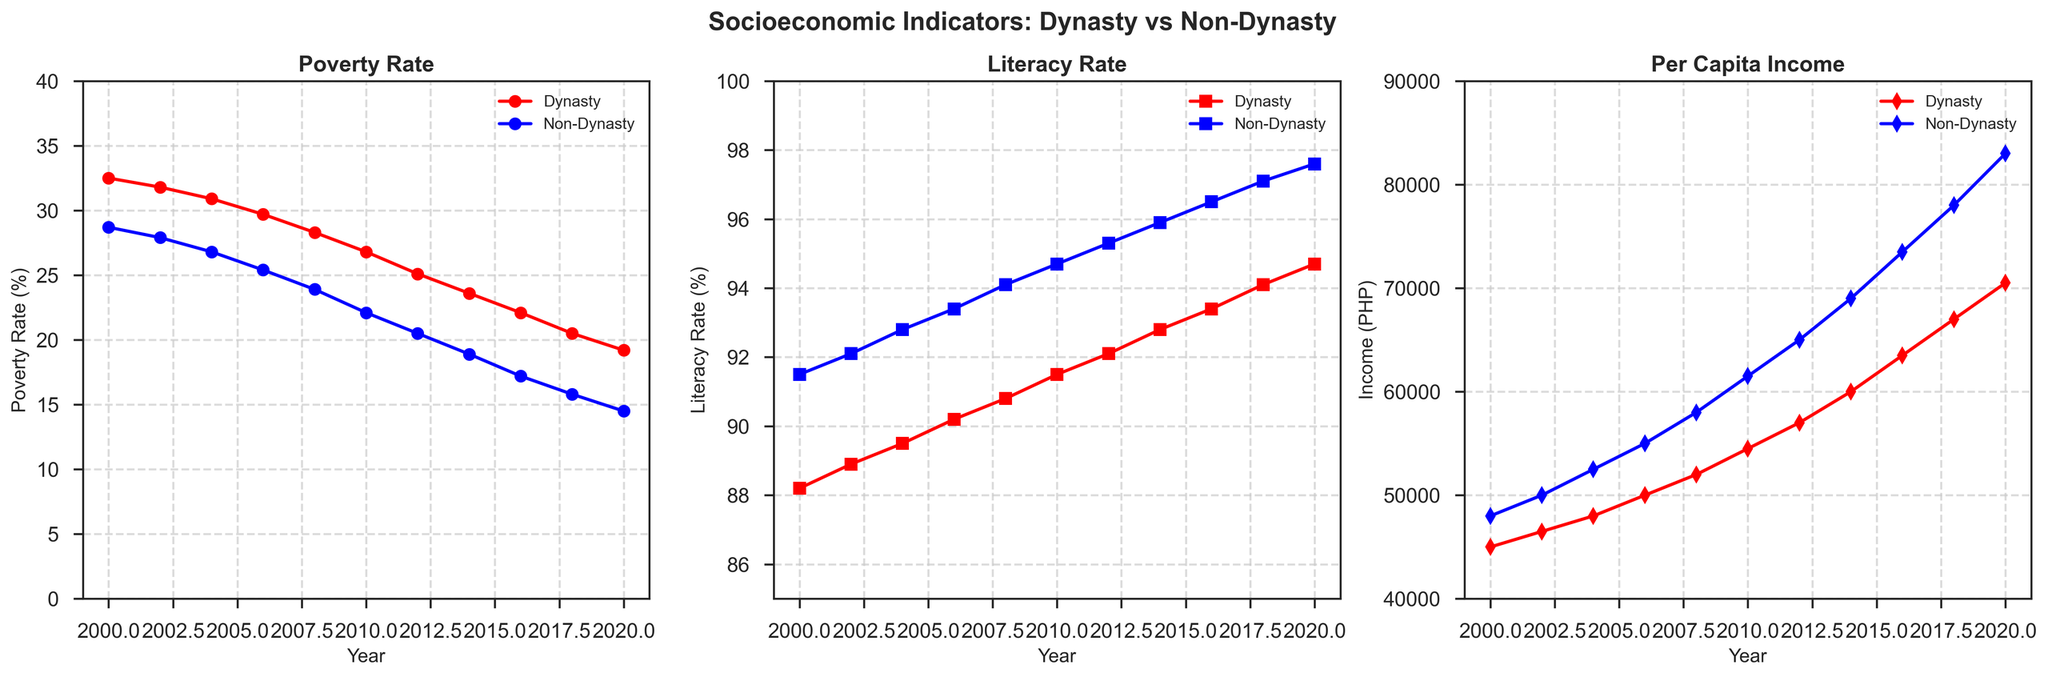Which area saw a greater reduction in poverty rate from 2000 to 2020, those governed by political dynasties or non-dynasty politicians? To find the reduction, subtract the 2020 poverty rate from the 2000 rate for both areas. For dynasties: 32.5% - 19.2% = 13.3%. For non-dynasties: 28.7% - 14.5% = 14.2%. The reduction is greater in areas governed by non-dynasty politicians (14.2%) compared to dynasties (13.3%).
Answer: Non-dynasty politicians In which year did the literacy rate in areas governed by non-dynasty politicians first reach 95%? Look at the literacy rate plotted for non-dynasty politicians and identify the first year it reaches or surpasses 95%. In 2012, the literacy rate for non-dynasties is 95.3%.
Answer: 2012 What is the difference in per capita income between areas governed by political dynasties and non-dynasty politicians in 2020? Subtract the per capita income of areas governed by political dynasties from that of non-dynasty politicians in 2020. 83000 PHP - 70500 PHP = 12500 PHP.
Answer: 12500 PHP How does the literacy rate in areas governed by political dynasties compare to non-dynasty areas in every year shown? Inspect the relative positions of the red and blue lines in the literacy rate plot across all years. The blue line (non-dynasty) is consistently above the red line (dynasty) indicating higher literacy rates in non-dynasty areas every year.
Answer: Non-dynasty areas always higher What is the trend in poverty rate for areas governed by political dynasties from 2000 to 2020? Observe the red line representing dynasty poverty rates over time. The trend shows a decreasing pattern from 32.5% in 2000 to 19.2% in 2020.
Answer: Decreasing Which year shows the greatest increase in per capita income for areas governed by political dynasties? Calculate the yearly increments in dynasty per capita income and find the largest one. The increment from 2014 to 2016 is the largest: 63500 - 60000 = 3500 PHP.
Answer: 2014-2016 Are the poverty rates in areas governed by non-dynasty politicians ever higher than those in areas governed by dynasties? Compare the red (dynasty) and blue (non-dynasty) lines in the poverty rate plot for all years. The blue line is consistently lower than the red line, indicating non-dynasty poverty rates are never higher.
Answer: No What was the per capita income for areas governed by political dynasties in 2010? Locate the red line (dynasty) in the per capita income plot and find its value for the year 2010, which is 54500 PHP.
Answer: 54500 PHP 